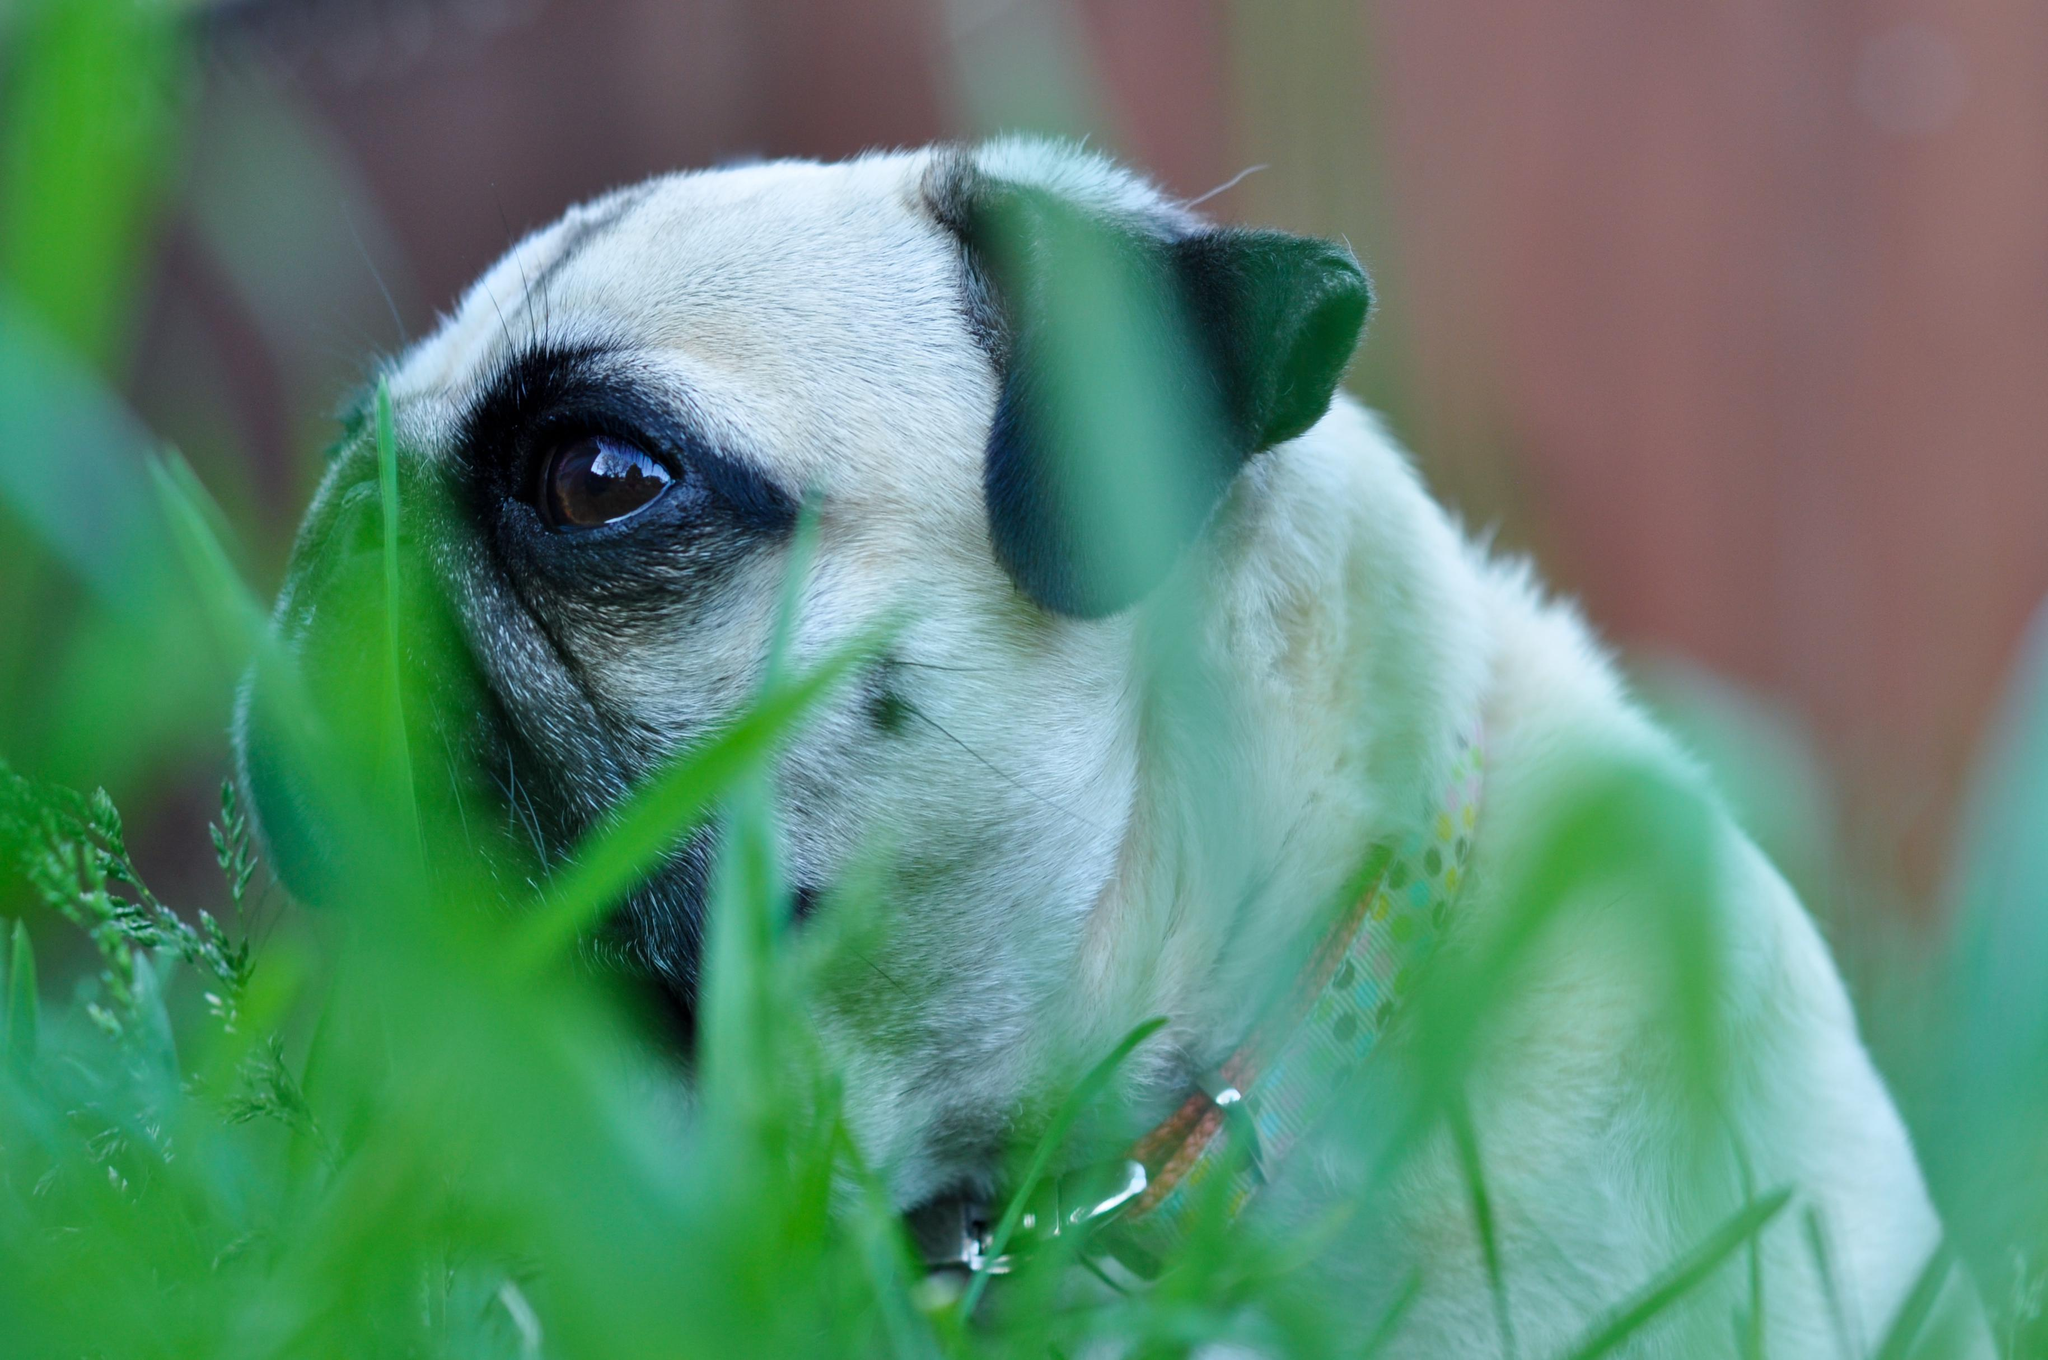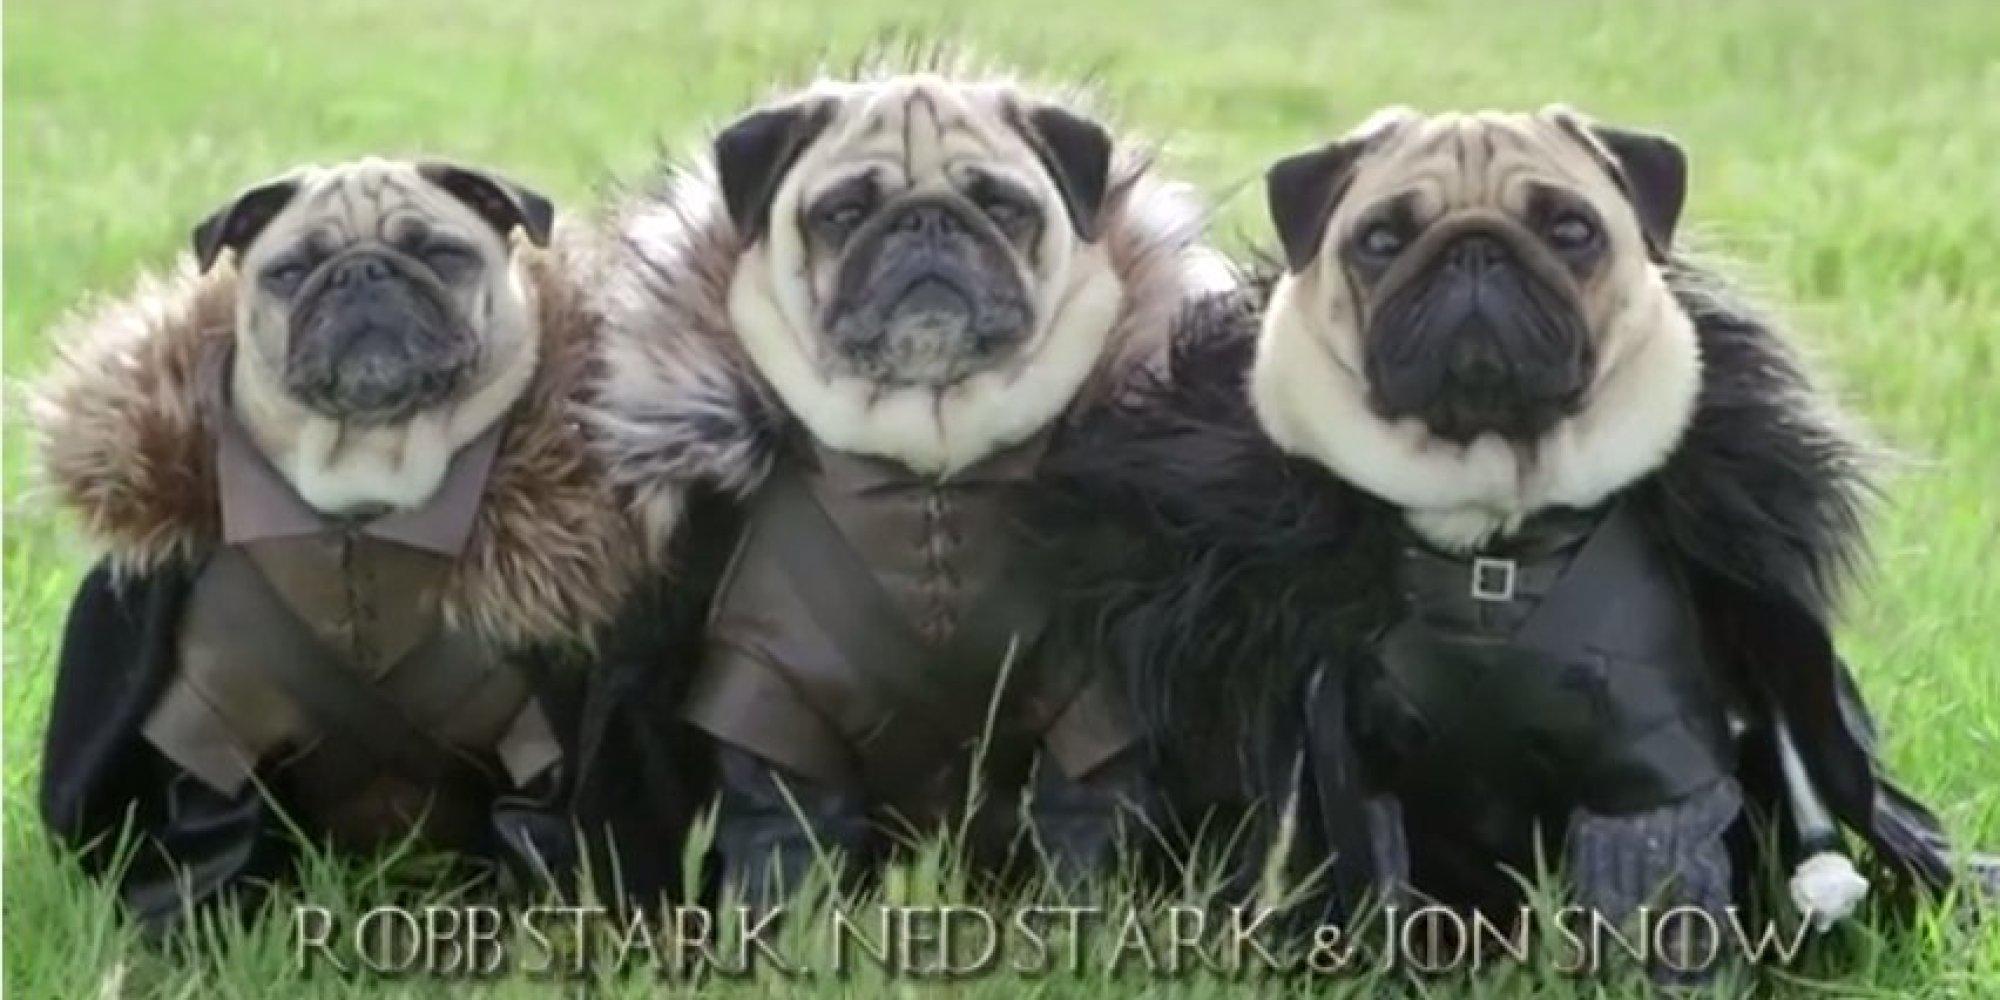The first image is the image on the left, the second image is the image on the right. Analyze the images presented: Is the assertion "Each image includes one beige pug with a dark muzzle, who is surrounded by some type of green foliage." valid? Answer yes or no. No. The first image is the image on the left, the second image is the image on the right. Examine the images to the left and right. Is the description "I at least one image there is a pug looking straight forward wearing a costume that circles its head." accurate? Answer yes or no. Yes. 